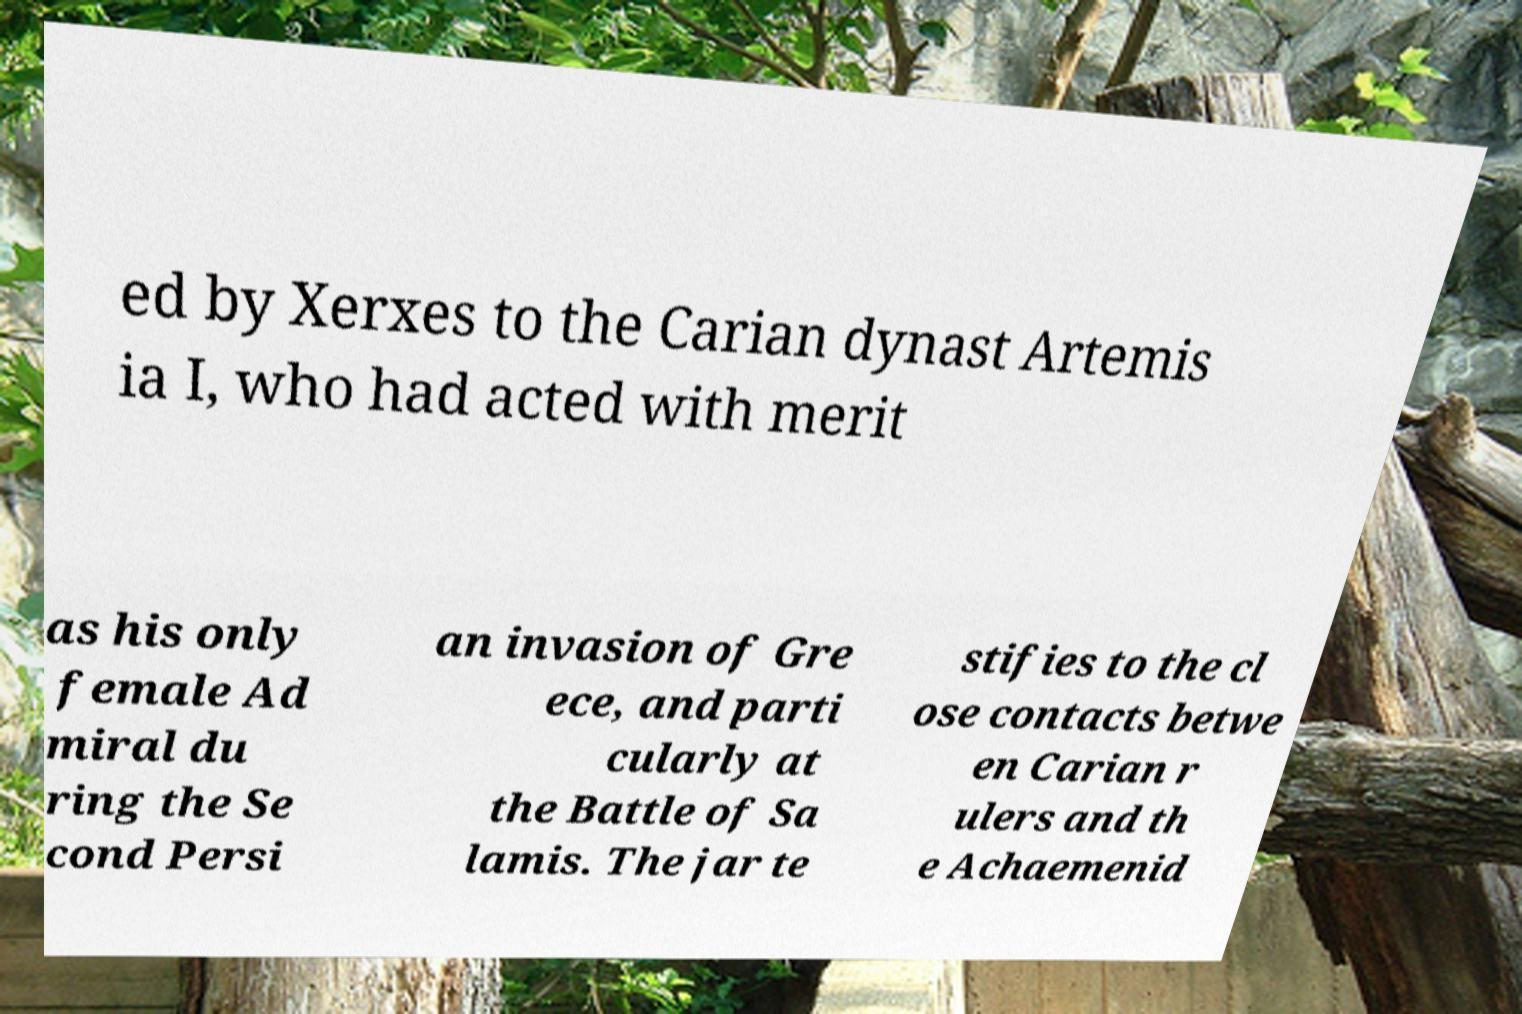What messages or text are displayed in this image? I need them in a readable, typed format. ed by Xerxes to the Carian dynast Artemis ia I, who had acted with merit as his only female Ad miral du ring the Se cond Persi an invasion of Gre ece, and parti cularly at the Battle of Sa lamis. The jar te stifies to the cl ose contacts betwe en Carian r ulers and th e Achaemenid 